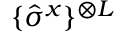Convert formula to latex. <formula><loc_0><loc_0><loc_500><loc_500>\{ \hat { \sigma } ^ { x } \} ^ { \otimes L }</formula> 